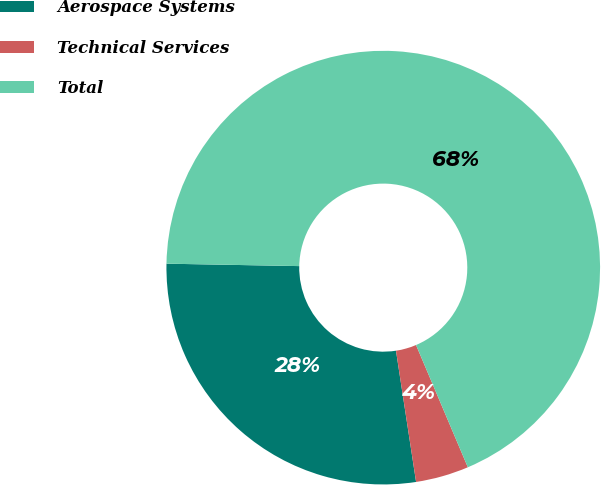Convert chart to OTSL. <chart><loc_0><loc_0><loc_500><loc_500><pie_chart><fcel>Aerospace Systems<fcel>Technical Services<fcel>Total<nl><fcel>27.71%<fcel>3.96%<fcel>68.33%<nl></chart> 